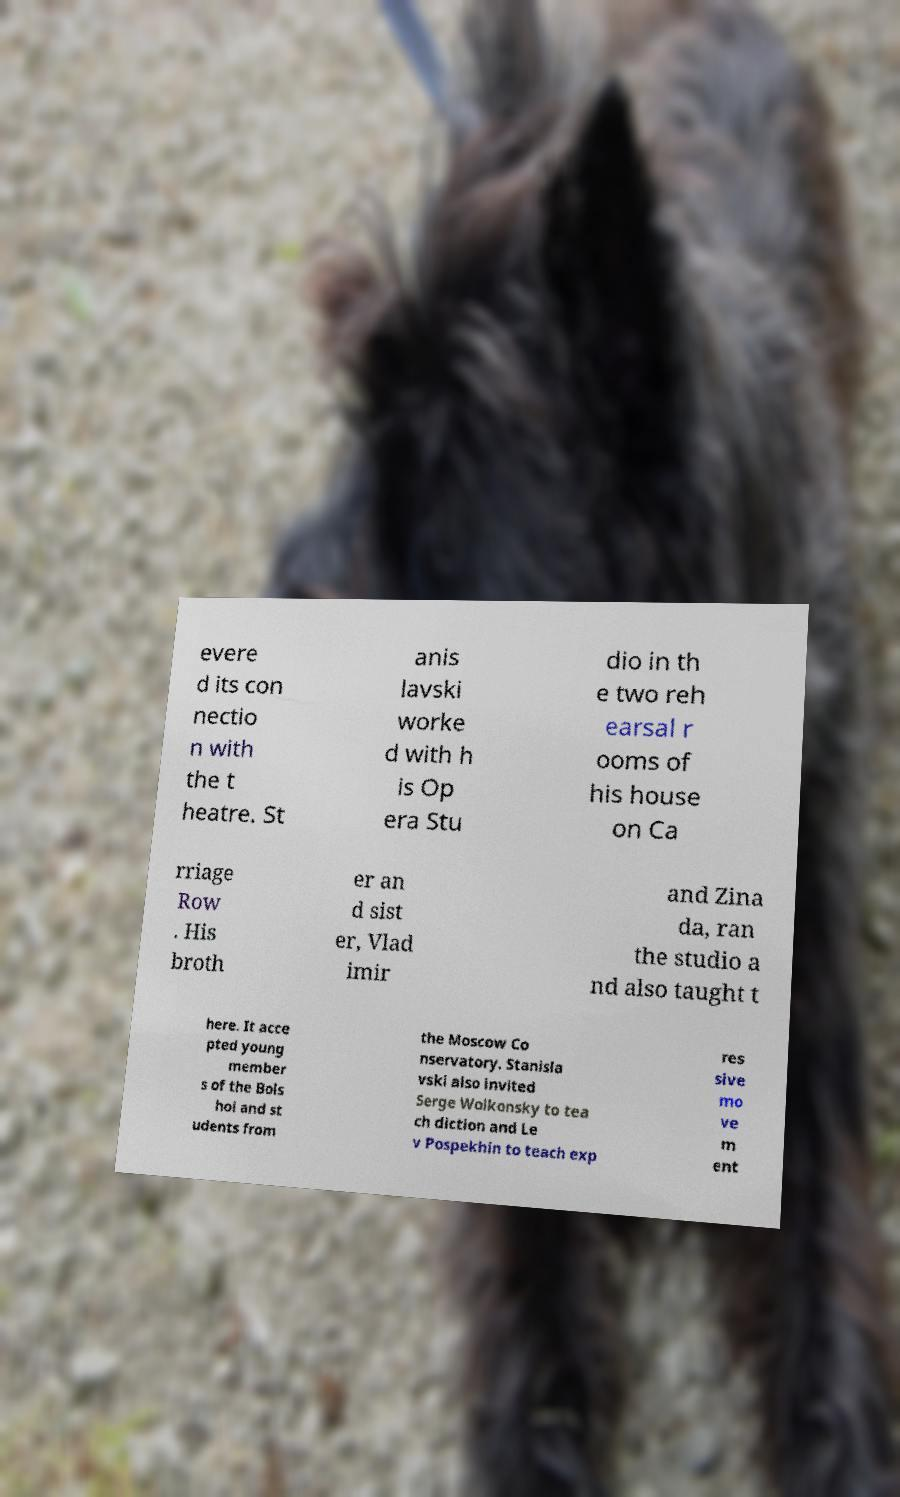Please read and relay the text visible in this image. What does it say? evere d its con nectio n with the t heatre. St anis lavski worke d with h is Op era Stu dio in th e two reh earsal r ooms of his house on Ca rriage Row . His broth er an d sist er, Vlad imir and Zina da, ran the studio a nd also taught t here. It acce pted young member s of the Bols hoi and st udents from the Moscow Co nservatory. Stanisla vski also invited Serge Wolkonsky to tea ch diction and Le v Pospekhin to teach exp res sive mo ve m ent 